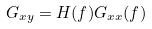<formula> <loc_0><loc_0><loc_500><loc_500>G _ { x y } = H ( f ) G _ { x x } ( f )</formula> 